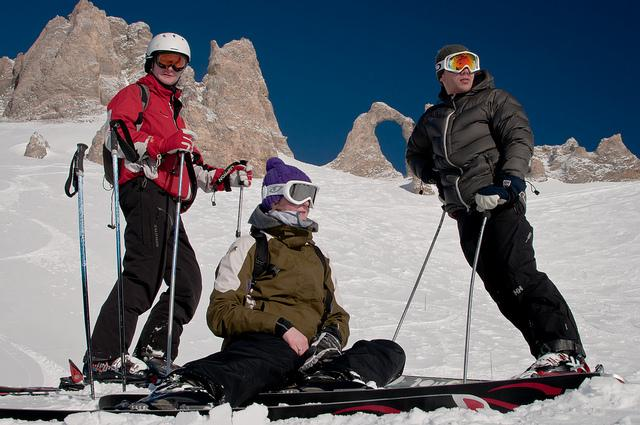What are the poles helping the man on the right do? Please explain your reasoning. stand. The man on the right is stationary. he is not performing tricks. 